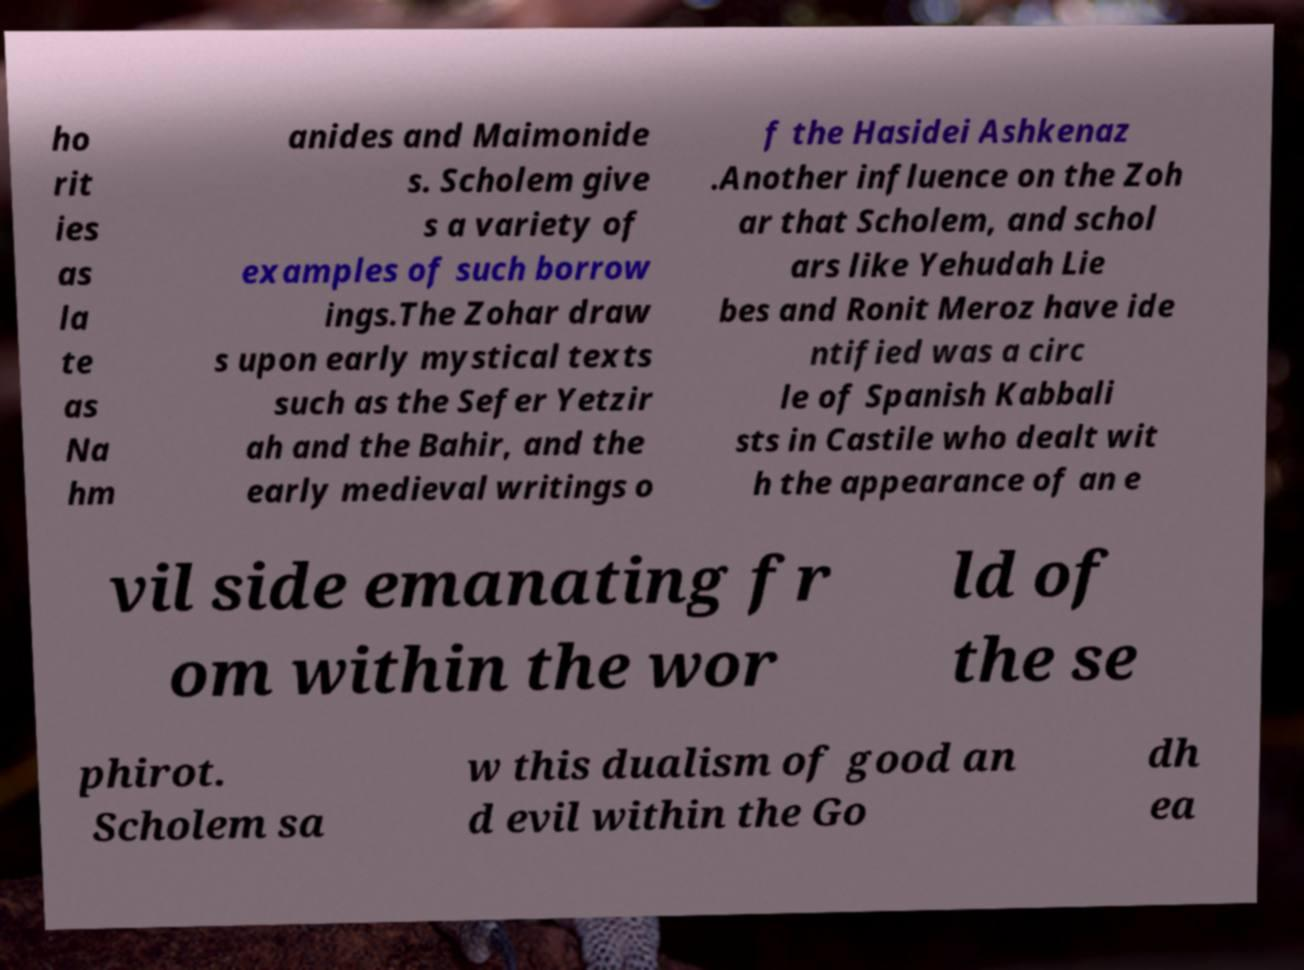Can you accurately transcribe the text from the provided image for me? ho rit ies as la te as Na hm anides and Maimonide s. Scholem give s a variety of examples of such borrow ings.The Zohar draw s upon early mystical texts such as the Sefer Yetzir ah and the Bahir, and the early medieval writings o f the Hasidei Ashkenaz .Another influence on the Zoh ar that Scholem, and schol ars like Yehudah Lie bes and Ronit Meroz have ide ntified was a circ le of Spanish Kabbali sts in Castile who dealt wit h the appearance of an e vil side emanating fr om within the wor ld of the se phirot. Scholem sa w this dualism of good an d evil within the Go dh ea 